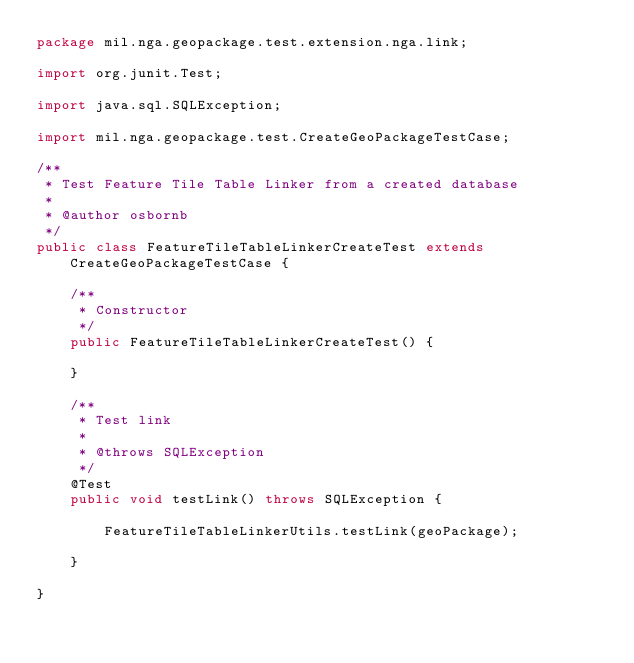<code> <loc_0><loc_0><loc_500><loc_500><_Java_>package mil.nga.geopackage.test.extension.nga.link;

import org.junit.Test;

import java.sql.SQLException;

import mil.nga.geopackage.test.CreateGeoPackageTestCase;

/**
 * Test Feature Tile Table Linker from a created database
 *
 * @author osbornb
 */
public class FeatureTileTableLinkerCreateTest extends CreateGeoPackageTestCase {

    /**
     * Constructor
     */
    public FeatureTileTableLinkerCreateTest() {

    }

    /**
     * Test link
     *
     * @throws SQLException
     */
    @Test
    public void testLink() throws SQLException {

        FeatureTileTableLinkerUtils.testLink(geoPackage);

    }

}
</code> 